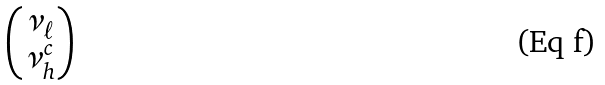Convert formula to latex. <formula><loc_0><loc_0><loc_500><loc_500>\begin{pmatrix} \nu _ { \ell } \\ \nu ^ { c } _ { h } \end{pmatrix}</formula> 